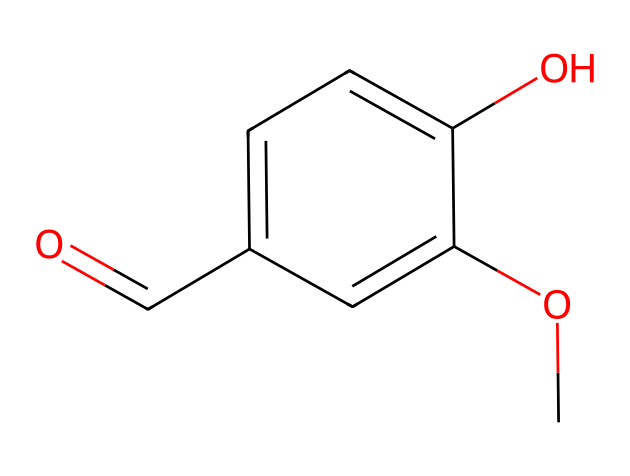What is the name of the chemical represented by this SMILES? The SMILES representation corresponds to vanillin, which is confirmed by the presence of the methoxy group and the aldehyde functional group in the molecular structure.
Answer: vanillin How many carbon atoms are present in vanillin? By analyzing the SMILES, we can identify six carbon atoms in the benzene ring and one from the methoxy group, plus one from the aldehyde group; thus, there are a total of eight carbon atoms.
Answer: eight What type of functional group is present at the end of the molecule? The aldehyde functional group is indicated by the 'C=O' that is attached to the carbon chain, making this the terminal functional group of the molecule.
Answer: aldehyde How many hydroxyl (OH) groups are in vanillin? By examining the structure based on the SMILES, I can confirm there is one hydroxyl (OH) group, evident from the 'O' in the structural formula.
Answer: one What aromatic property does vanillin possess? Vanillin contains a benzene ring as part of its structure, which is characteristic of all aromatic compounds, indicating that it is aromatic due to the cyclic, planar arrangement of atoms with delocalized pi electrons.
Answer: aromatic What is the molecular formula for vanillin? To determine this, we can count the atoms present in the molecule indicated by the SMILES: C8H8O3 gives us the correct count of carbon, hydrogen, and oxygen atoms in vanillin.
Answer: C8H8O3 What characterizes the aromatic nature of vanillin? The structural presence of alternating double bonds in the benzene ring, coupled with resonance stability due to delocalized electrons, truly characterizes the aromatic nature of vanillin.
Answer: resonance 